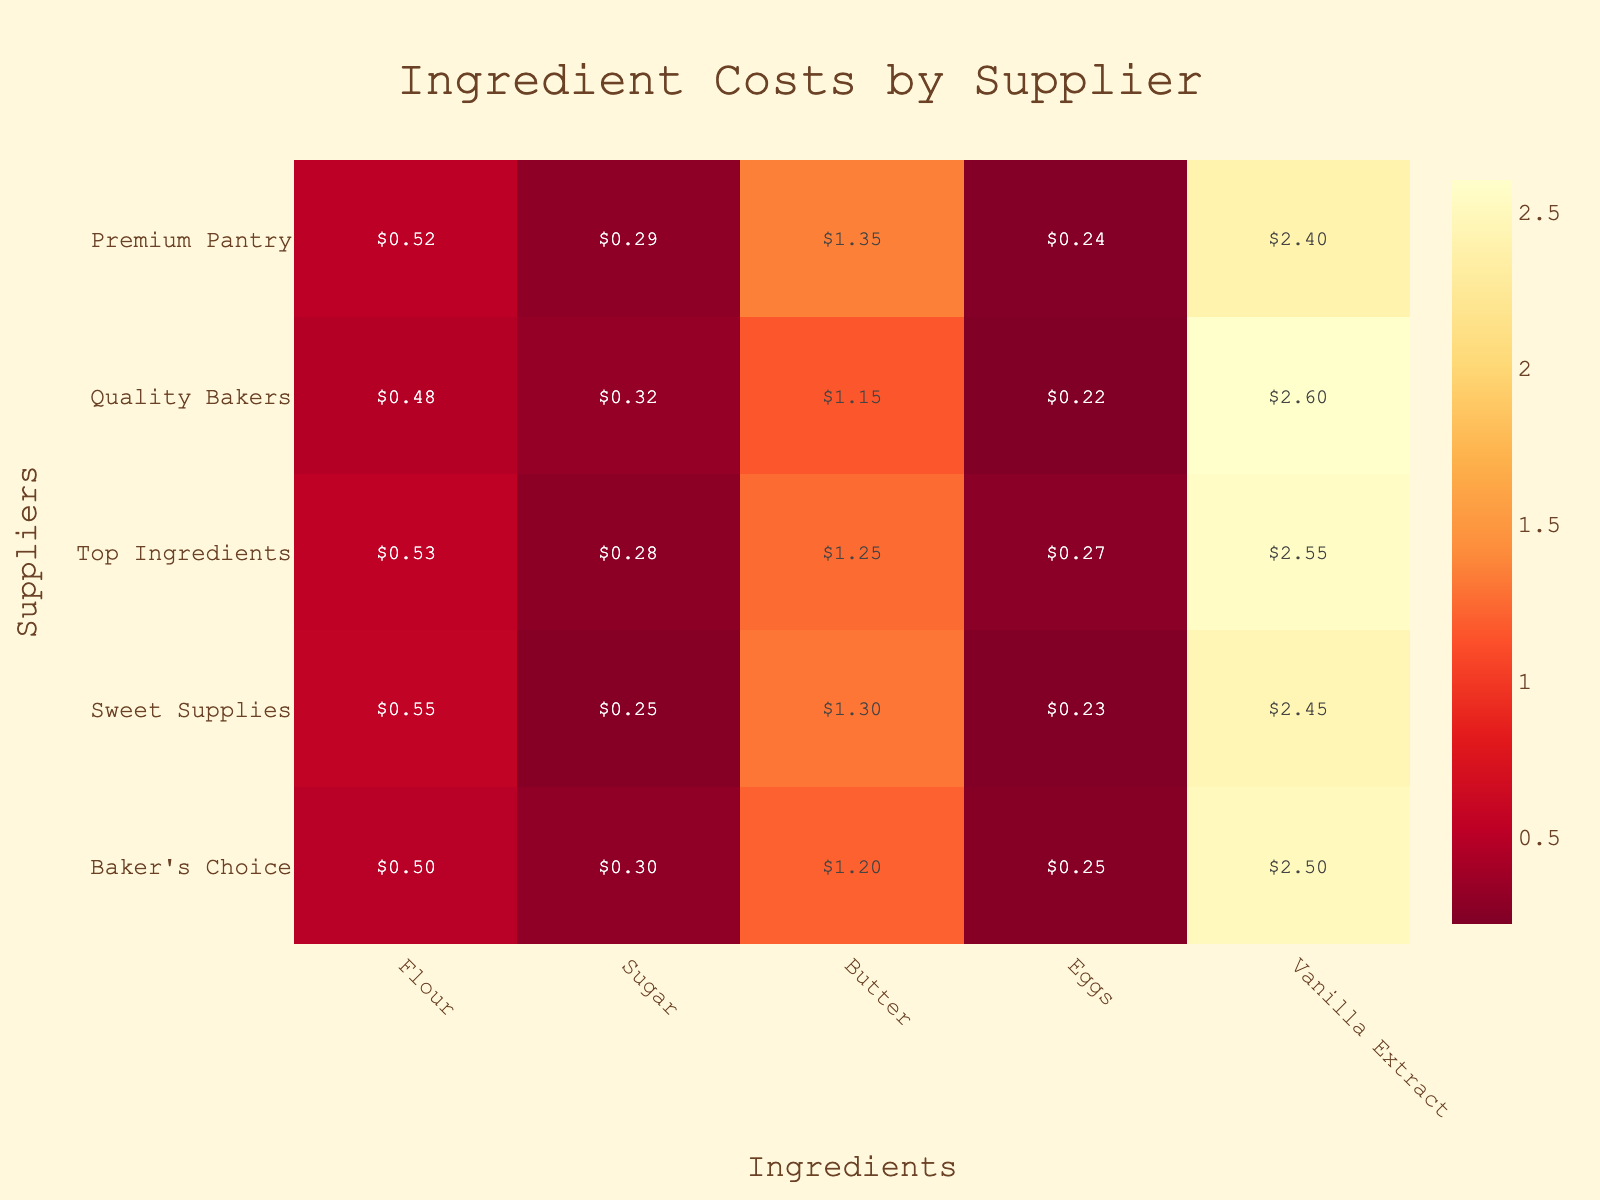What's the title of the heatmap? Look at the top-center part of the heatmap, where the title is usually located.
Answer: "Ingredient Costs by Supplier" What is the cost of Vanilla Extract from Quality Bakers? Locate "Quality Bakers" on the y-axis and "Vanilla Extract" on the x-axis. The intersecting cell shows the cost.
Answer: $2.60 Which supplier offers the lowest cost for Butter? Identify the column for "Butter" and compare the values across all suppliers. The smallest value will be the answer.
Answer: Quality Bakers Across all suppliers, what is the average cost of Eggs? Sum the values in the "Eggs" column and divide by the number of suppliers. Calculation: (0.25 + 0.23 + 0.27 + 0.22 + 0.24) / 5 = 1.21 / 5 = 0.242
Answer: $0.24 Which ingredient has the highest average cost across all suppliers? Calculate the average cost for each ingredient. Compare these averages to identify the highest one. Detailed calculation: Flour: (0.50 + 0.55 + 0.53 + 0.48 + 0.52)/5 = 0.516; Sugar: (0.30 + 0.25 + 0.28 + 0.32 + 0.29)/5 = 0.288; Butter: (1.20 + 1.30 + 1.25 + 1.15 + 1.35)/5 = 1.25; Eggs: (0.25 + 0.23 + 0.27 + 0.22 + 0.24)/5 = 0.242; Vanilla Extract: (2.50 + 2.45 + 2.55 + 2.60 + 2.40)/5 = 2.50. Highest is Vanilla Extract.
Answer: Vanilla Extract For which ingredient is there the least variation in cost across suppliers? Calculate the range (difference between maximum and minimum) for each ingredient. The smallest range indicates the least variation. Detailed calculation: Flour: max(0.55)-min(0.48)=0.07; Sugar: max(0.32)-min(0.25)=0.07; Butter: max(1.35)-min(1.15)=0.20; Eggs: max(0.27)-min(0.22)=0.05; Vanilla Extract: max(2.60)-min(2.40)=0.20. Least variation is Eggs.
Answer: Eggs Which supplier generally has the lowest overall ingredient costs? To determine this, compare the average cost of all ingredients for each supplier. Detailed calculation: Baker's Choice: (0.50+0.30+1.20+0.25+2.50)/5 = 0.95; Sweet Supplies: (0.55+0.25+1.30+0.23+2.45)/5 = 0.956; Top Ingredients: (0.53+0.28+1.25+0.27+2.55)/5 = 0.976; Quality Bakers: (0.48+0.32+1.15+0.22+2.60)/5 = 0.954; Premium Pantry: (0.52+0.29+1.35+0.24+2.40)/5 = 0.96. Lowest is Baker's Choice.
Answer: Baker's Choice How does the cost of Sugar compare between Sweet Supplies and Top Ingredients? Look at the "Sugar" costs for both suppliers: Sweet Supplies ($0.25) and Top Ingredients ($0.28). Compare them directly.
Answer: Sweet Supplies is cheaper Which ingredient has the highest cost from any supplier? Identify the maximum cost value across all cells in the heatmap.
Answer: Vanilla Extract from Quality Bakers ($2.60) When it comes to Flour, which supplier is the most economical? Locate the "Flour" costs across all suppliers and identify the lowest value.
Answer: Quality Bakers 